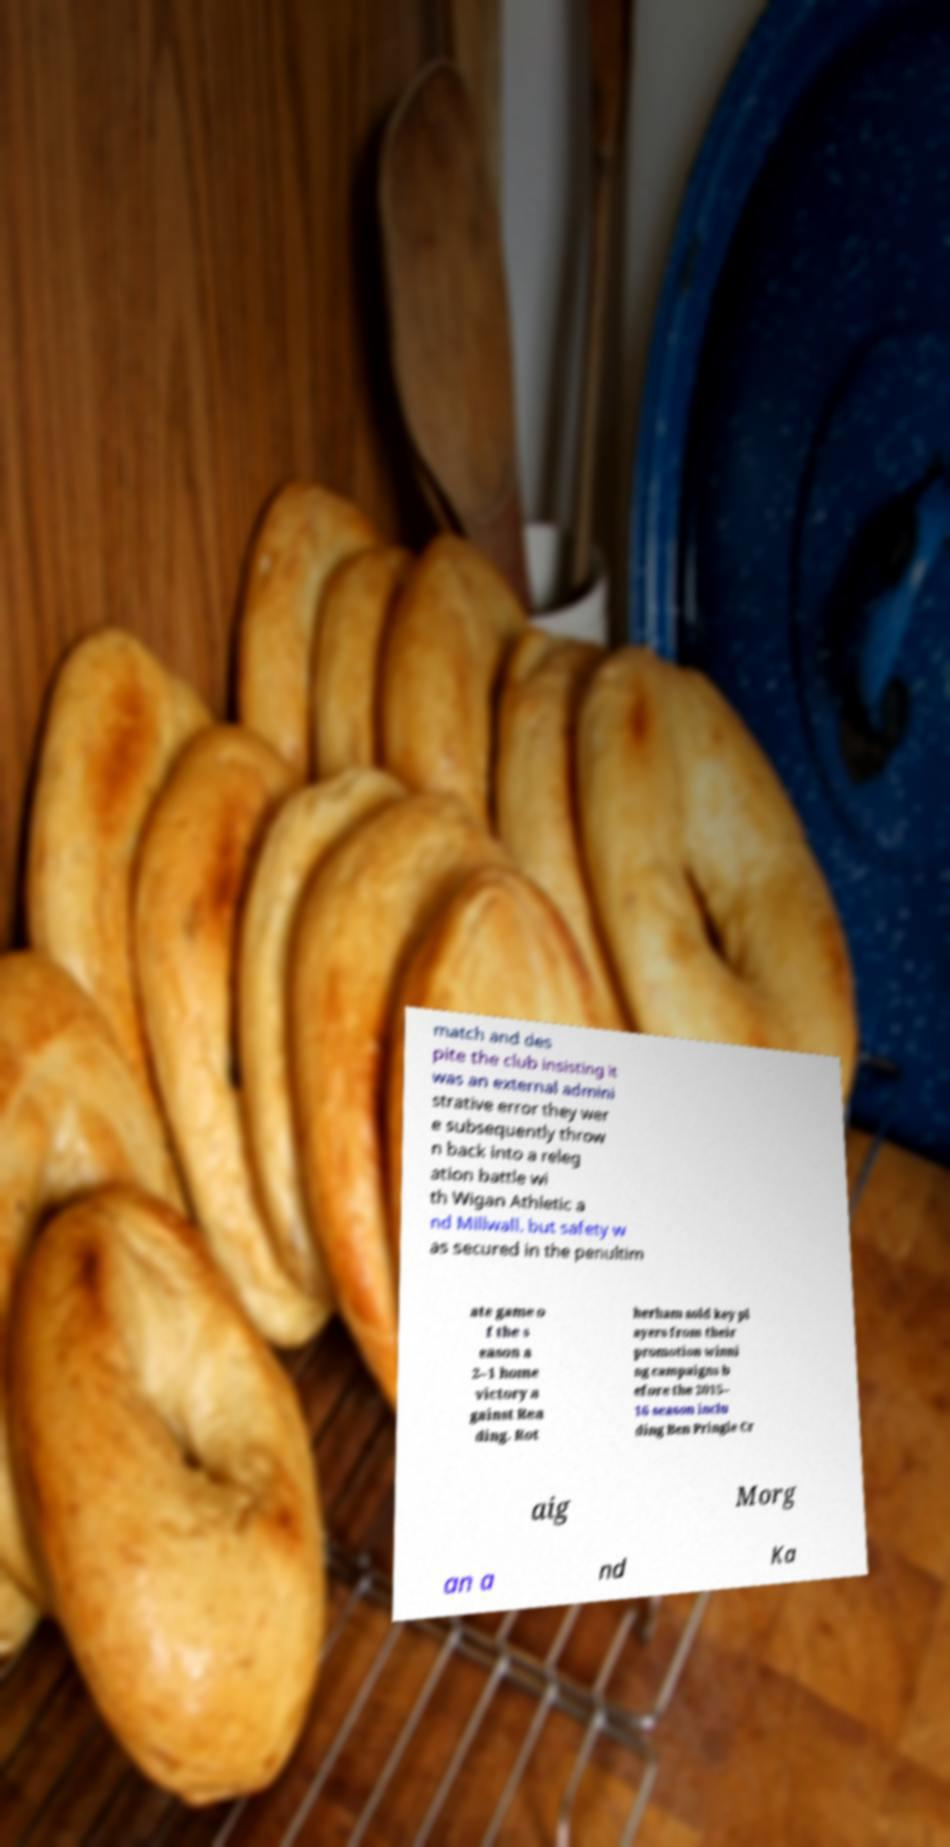There's text embedded in this image that I need extracted. Can you transcribe it verbatim? match and des pite the club insisting it was an external admini strative error they wer e subsequently throw n back into a releg ation battle wi th Wigan Athletic a nd Millwall. but safety w as secured in the penultim ate game o f the s eason a 2–1 home victory a gainst Rea ding. Rot herham sold key pl ayers from their promotion winni ng campaigns b efore the 2015– 16 season inclu ding Ben Pringle Cr aig Morg an a nd Ka 